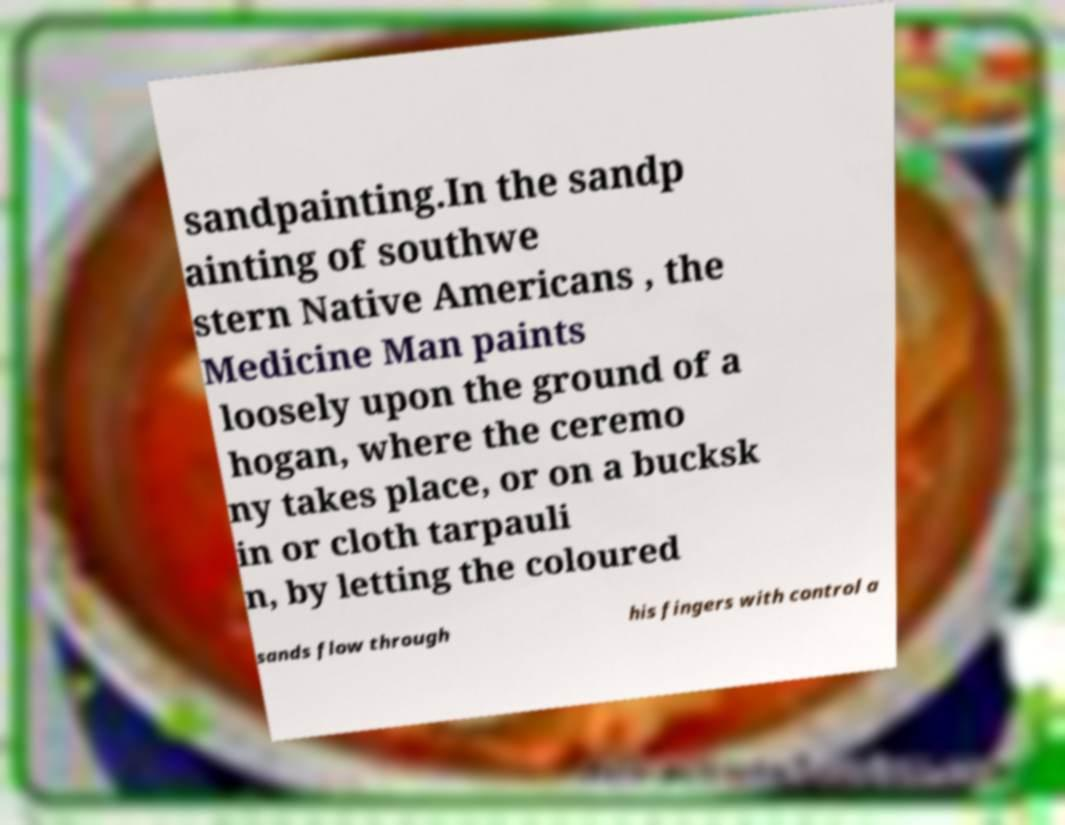Can you read and provide the text displayed in the image?This photo seems to have some interesting text. Can you extract and type it out for me? sandpainting.In the sandp ainting of southwe stern Native Americans , the Medicine Man paints loosely upon the ground of a hogan, where the ceremo ny takes place, or on a bucksk in or cloth tarpauli n, by letting the coloured sands flow through his fingers with control a 